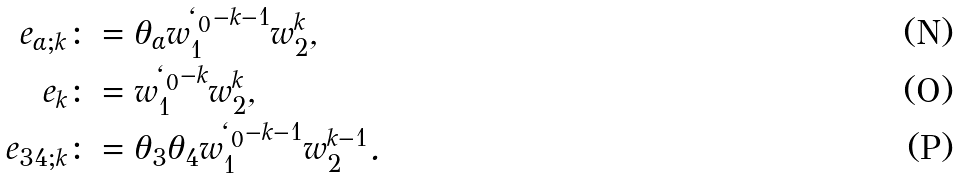<formula> <loc_0><loc_0><loc_500><loc_500>e _ { \alpha ; k } & \colon = \theta _ { \alpha } w _ { 1 } ^ { \ell _ { 0 } - k - 1 } w _ { 2 } ^ { k } , \\ e _ { k } & \colon = w _ { 1 } ^ { \ell _ { 0 } - k } w _ { 2 } ^ { k } , \\ e _ { 3 4 ; k } & \colon = \theta _ { 3 } \theta _ { 4 } w _ { 1 } ^ { \ell _ { 0 } - k - 1 } w _ { 2 } ^ { k - 1 } .</formula> 